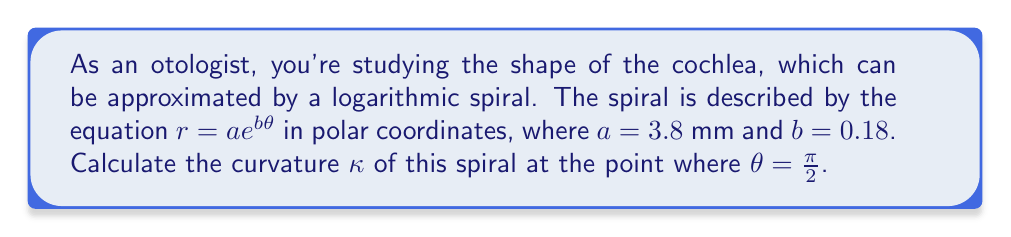Could you help me with this problem? To calculate the curvature of a logarithmic spiral, we'll follow these steps:

1) The curvature of a plane curve in polar coordinates is given by:

   $$\kappa = \frac{|r^2 + 2(r')^2 - rr''|}{(r^2 + (r')^2)^{3/2}}$$

2) For a logarithmic spiral $r = ae^{b\theta}$, we need to find $r'$ and $r''$:
   
   $r' = \frac{dr}{d\theta} = abe^{b\theta}$
   $r'' = \frac{d^2r}{d\theta^2} = ab^2e^{b\theta}$

3) Substituting these into the curvature formula:

   $$\kappa = \frac{|(ae^{b\theta})^2 + 2(abe^{b\theta})^2 - ae^{b\theta}ab^2e^{b\theta}|}{((ae^{b\theta})^2 + (abe^{b\theta})^2)^{3/2}}$$

4) Simplifying:

   $$\kappa = \frac{|a^2e^{2b\theta}(1 + 2b^2 - b^2)|}{a^3e^{3b\theta}(1 + b^2)^{3/2}} = \frac{|1 + b^2|}{ae^{b\theta}(1 + b^2)^{3/2}}$$

5) Now, we can substitute the given values: $a = 3.8$ mm, $b = 0.18$, and $\theta = \frac{\pi}{2}$:

   $$\kappa = \frac{|1 + 0.18^2|}{3.8e^{0.18\frac{\pi}{2}}(1 + 0.18^2)^{3/2}}$$

6) Calculating this:

   $$\kappa \approx 0.2297 \text{ mm}^{-1}$$
Answer: $\kappa \approx 0.2297 \text{ mm}^{-1}$ 